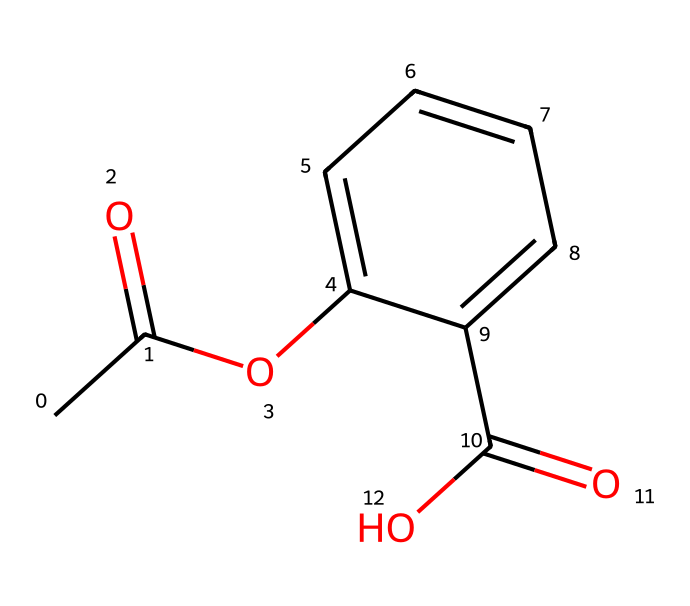What is the molecular formula of this compound? To determine the molecular formula, count the atoms of each element represented in the SMILES. The structure has: 9 carbon (C) atoms, 10 hydrogen (H) atoms, and 4 oxygen (O) atoms. Therefore, the molecular formula is C9H10O4.
Answer: C9H10O4 How many carbon atoms are present in this compound? By looking at the SMILES, we can count the number of carbon atoms. There are 9 carbon atoms in total.
Answer: 9 What type of functional groups are present in this chemical structure? Analyze the structure for key functional groups: there are two carbonyls (C=O) due to the two acyl groups, and an ester (–O–C=O) which indicates both the presence of esters and carboxylic acids.
Answer: ester, carboxylic acid Which part of this chemical contributes to its pain-relieving properties? The presence of specific functional groups such as the ester and the carboxylic acid contributes to the pain-relieving properties, as esters are often associated with anti-inflammatory effects.
Answer: ester, carboxylic acid How many total double bonds are present in this compound? The SMILES representation shows two double bonds: one in the ester functional group and one in the carboxylic acid group. Therefore, there are 2 double bonds.
Answer: 2 What is the significance of the acetyl group in this chemical? The acetyl group (–C(=O)CH3) is crucial for its ability to penetrate the skin and enhance anti-inflammatory effects. It is often responsible for the efficacy of analgesic properties in topical liniments.
Answer: acetyl group 